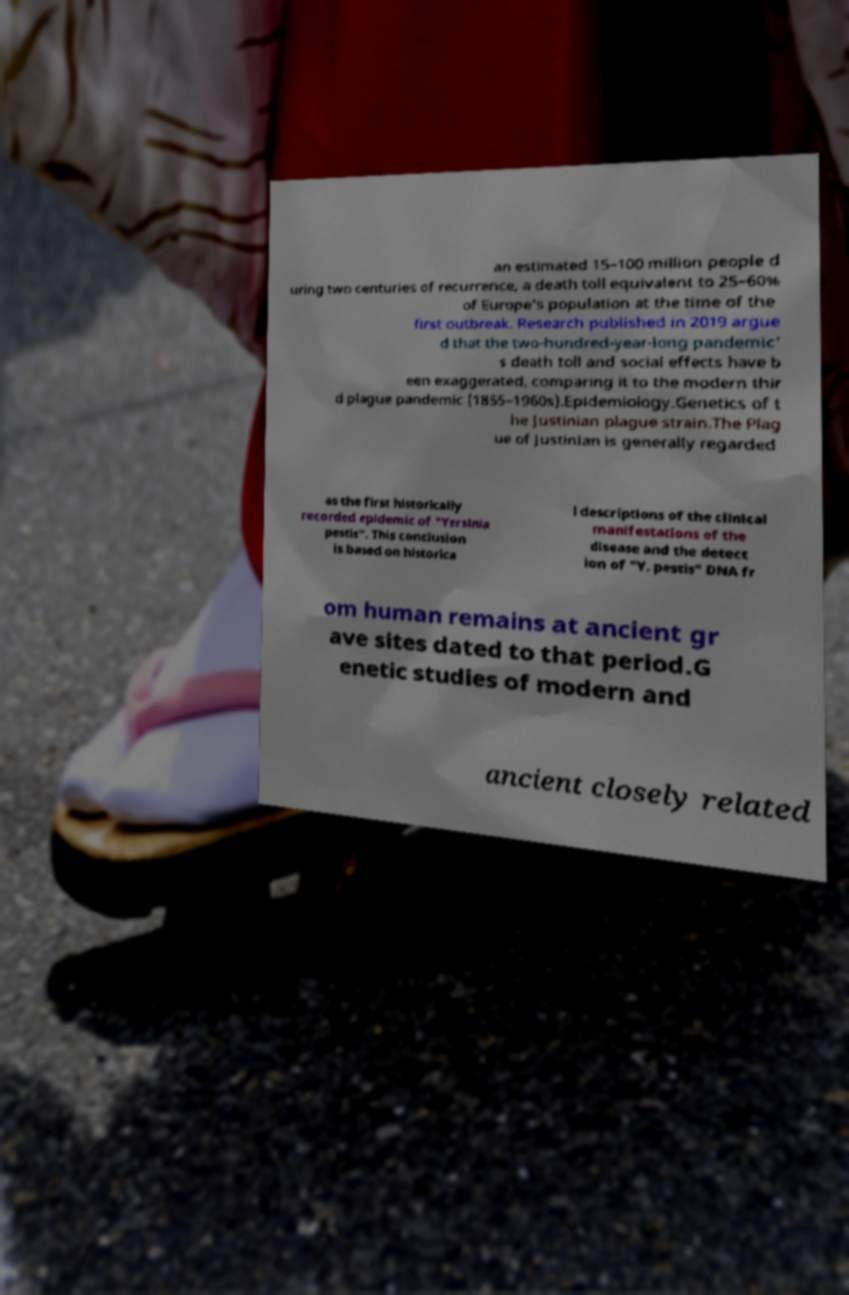I need the written content from this picture converted into text. Can you do that? an estimated 15–100 million people d uring two centuries of recurrence, a death toll equivalent to 25–60% of Europe's population at the time of the first outbreak. Research published in 2019 argue d that the two-hundred-year-long pandemic' s death toll and social effects have b een exaggerated, comparing it to the modern thir d plague pandemic (1855–1960s).Epidemiology.Genetics of t he Justinian plague strain.The Plag ue of Justinian is generally regarded as the first historically recorded epidemic of "Yersinia pestis". This conclusion is based on historica l descriptions of the clinical manifestations of the disease and the detect ion of "Y. pestis" DNA fr om human remains at ancient gr ave sites dated to that period.G enetic studies of modern and ancient closely related 